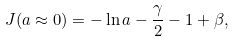<formula> <loc_0><loc_0><loc_500><loc_500>J ( a \approx 0 ) = - \ln a - { \frac { \gamma } { 2 } } - 1 + \beta ,</formula> 